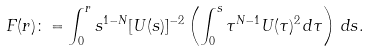Convert formula to latex. <formula><loc_0><loc_0><loc_500><loc_500>F ( r ) \colon = \int _ { 0 } ^ { r } s ^ { 1 - N } [ U ( s ) ] ^ { - 2 } \left ( \int _ { 0 } ^ { s } \tau ^ { N - 1 } U ( \tau ) ^ { 2 } \, d \tau \right ) \, d s .</formula> 